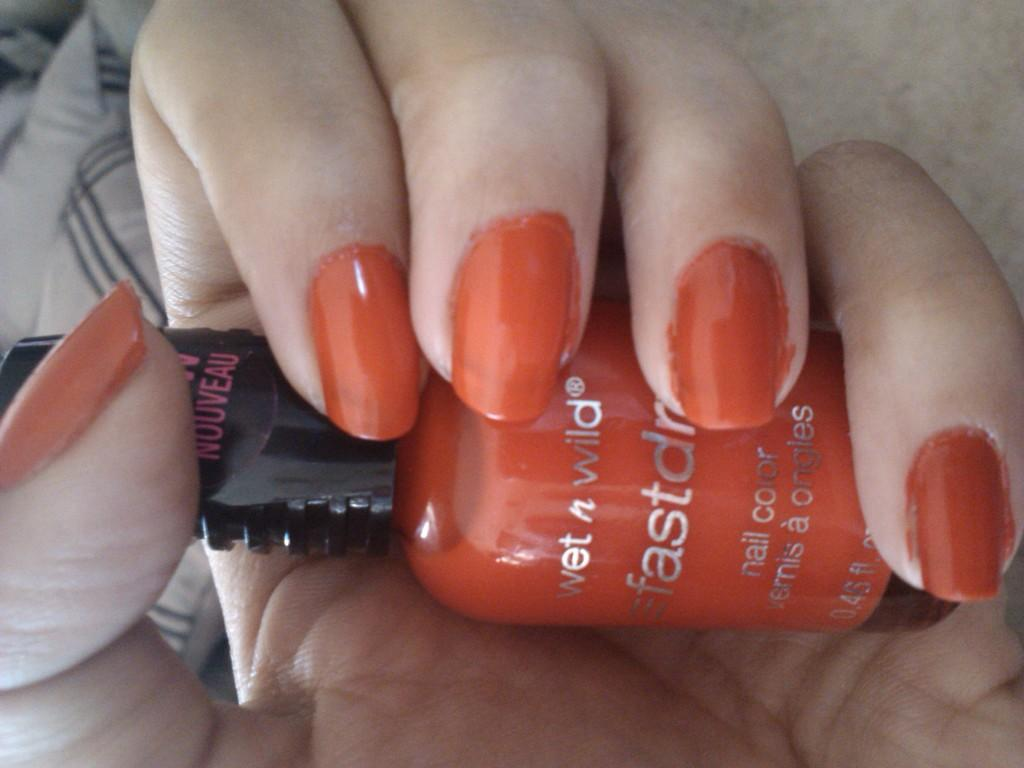What is present on the nails in the image? There are colored nails in the image. What is applied to the nails to achieve the color? Nail polish is visible on the nails. What type of oatmeal is being served to the children in the image? There is no oatmeal or children present in the image; it only features colored nails with nail polish. 